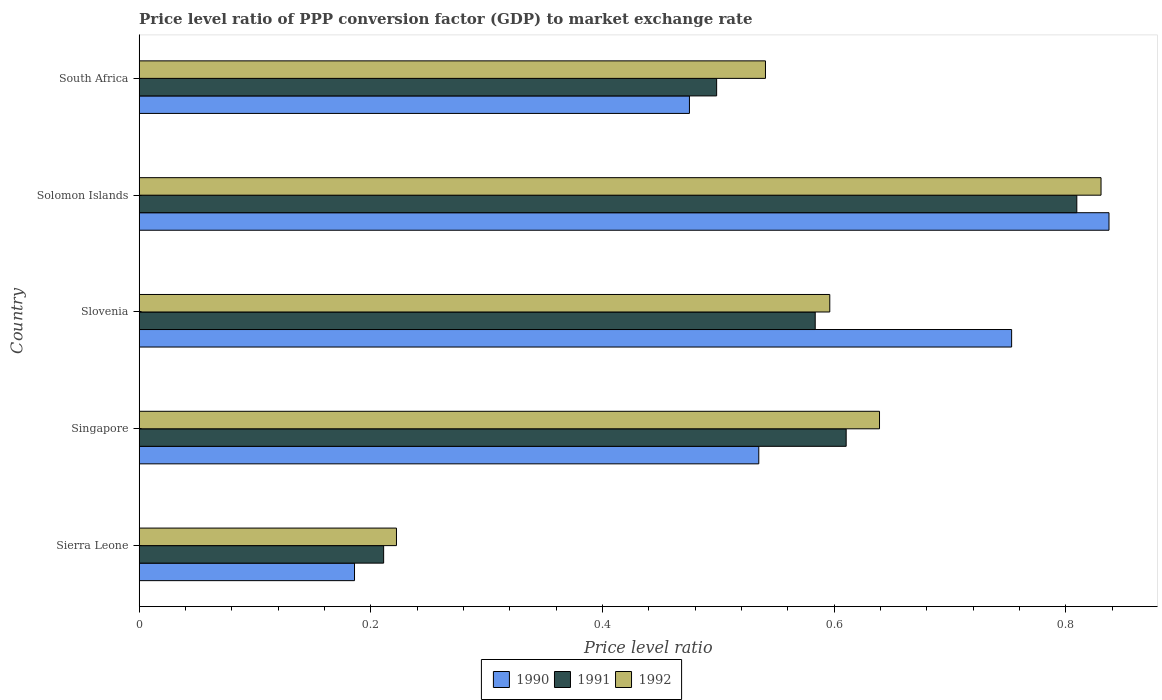How many groups of bars are there?
Your answer should be compact. 5. What is the label of the 5th group of bars from the top?
Your response must be concise. Sierra Leone. What is the price level ratio in 1991 in South Africa?
Make the answer very short. 0.5. Across all countries, what is the maximum price level ratio in 1991?
Your answer should be very brief. 0.81. Across all countries, what is the minimum price level ratio in 1990?
Provide a succinct answer. 0.19. In which country was the price level ratio in 1992 maximum?
Your answer should be compact. Solomon Islands. In which country was the price level ratio in 1991 minimum?
Your response must be concise. Sierra Leone. What is the total price level ratio in 1992 in the graph?
Ensure brevity in your answer.  2.83. What is the difference between the price level ratio in 1992 in Sierra Leone and that in Solomon Islands?
Provide a short and direct response. -0.61. What is the difference between the price level ratio in 1990 in Sierra Leone and the price level ratio in 1992 in Singapore?
Offer a very short reply. -0.45. What is the average price level ratio in 1990 per country?
Make the answer very short. 0.56. What is the difference between the price level ratio in 1992 and price level ratio in 1991 in Slovenia?
Give a very brief answer. 0.01. What is the ratio of the price level ratio in 1991 in Singapore to that in Solomon Islands?
Offer a very short reply. 0.75. Is the difference between the price level ratio in 1992 in Slovenia and Solomon Islands greater than the difference between the price level ratio in 1991 in Slovenia and Solomon Islands?
Give a very brief answer. No. What is the difference between the highest and the second highest price level ratio in 1992?
Give a very brief answer. 0.19. What is the difference between the highest and the lowest price level ratio in 1992?
Make the answer very short. 0.61. In how many countries, is the price level ratio in 1992 greater than the average price level ratio in 1992 taken over all countries?
Provide a succinct answer. 3. Is the sum of the price level ratio in 1991 in Sierra Leone and Solomon Islands greater than the maximum price level ratio in 1992 across all countries?
Make the answer very short. Yes. What does the 3rd bar from the top in South Africa represents?
Offer a terse response. 1990. What does the 2nd bar from the bottom in Solomon Islands represents?
Give a very brief answer. 1991. Is it the case that in every country, the sum of the price level ratio in 1991 and price level ratio in 1990 is greater than the price level ratio in 1992?
Your response must be concise. Yes. How many bars are there?
Your response must be concise. 15. What is the difference between two consecutive major ticks on the X-axis?
Provide a succinct answer. 0.2. Where does the legend appear in the graph?
Give a very brief answer. Bottom center. What is the title of the graph?
Ensure brevity in your answer.  Price level ratio of PPP conversion factor (GDP) to market exchange rate. What is the label or title of the X-axis?
Provide a short and direct response. Price level ratio. What is the Price level ratio of 1990 in Sierra Leone?
Give a very brief answer. 0.19. What is the Price level ratio of 1991 in Sierra Leone?
Your answer should be very brief. 0.21. What is the Price level ratio in 1992 in Sierra Leone?
Offer a very short reply. 0.22. What is the Price level ratio of 1990 in Singapore?
Your answer should be compact. 0.53. What is the Price level ratio in 1991 in Singapore?
Offer a terse response. 0.61. What is the Price level ratio in 1992 in Singapore?
Your response must be concise. 0.64. What is the Price level ratio of 1990 in Slovenia?
Give a very brief answer. 0.75. What is the Price level ratio of 1991 in Slovenia?
Your response must be concise. 0.58. What is the Price level ratio of 1992 in Slovenia?
Give a very brief answer. 0.6. What is the Price level ratio in 1990 in Solomon Islands?
Provide a succinct answer. 0.84. What is the Price level ratio in 1991 in Solomon Islands?
Make the answer very short. 0.81. What is the Price level ratio of 1992 in Solomon Islands?
Your answer should be compact. 0.83. What is the Price level ratio of 1990 in South Africa?
Your answer should be compact. 0.48. What is the Price level ratio in 1991 in South Africa?
Give a very brief answer. 0.5. What is the Price level ratio in 1992 in South Africa?
Offer a terse response. 0.54. Across all countries, what is the maximum Price level ratio of 1990?
Keep it short and to the point. 0.84. Across all countries, what is the maximum Price level ratio of 1991?
Your response must be concise. 0.81. Across all countries, what is the maximum Price level ratio of 1992?
Provide a short and direct response. 0.83. Across all countries, what is the minimum Price level ratio of 1990?
Provide a short and direct response. 0.19. Across all countries, what is the minimum Price level ratio in 1991?
Your response must be concise. 0.21. Across all countries, what is the minimum Price level ratio in 1992?
Provide a succinct answer. 0.22. What is the total Price level ratio in 1990 in the graph?
Provide a short and direct response. 2.79. What is the total Price level ratio in 1991 in the graph?
Your answer should be very brief. 2.71. What is the total Price level ratio of 1992 in the graph?
Give a very brief answer. 2.83. What is the difference between the Price level ratio of 1990 in Sierra Leone and that in Singapore?
Provide a succinct answer. -0.35. What is the difference between the Price level ratio of 1991 in Sierra Leone and that in Singapore?
Provide a short and direct response. -0.4. What is the difference between the Price level ratio of 1992 in Sierra Leone and that in Singapore?
Offer a very short reply. -0.42. What is the difference between the Price level ratio in 1990 in Sierra Leone and that in Slovenia?
Give a very brief answer. -0.57. What is the difference between the Price level ratio in 1991 in Sierra Leone and that in Slovenia?
Provide a succinct answer. -0.37. What is the difference between the Price level ratio of 1992 in Sierra Leone and that in Slovenia?
Your answer should be very brief. -0.37. What is the difference between the Price level ratio in 1990 in Sierra Leone and that in Solomon Islands?
Offer a very short reply. -0.65. What is the difference between the Price level ratio in 1991 in Sierra Leone and that in Solomon Islands?
Provide a short and direct response. -0.6. What is the difference between the Price level ratio in 1992 in Sierra Leone and that in Solomon Islands?
Keep it short and to the point. -0.61. What is the difference between the Price level ratio of 1990 in Sierra Leone and that in South Africa?
Your response must be concise. -0.29. What is the difference between the Price level ratio of 1991 in Sierra Leone and that in South Africa?
Offer a very short reply. -0.29. What is the difference between the Price level ratio in 1992 in Sierra Leone and that in South Africa?
Give a very brief answer. -0.32. What is the difference between the Price level ratio in 1990 in Singapore and that in Slovenia?
Your response must be concise. -0.22. What is the difference between the Price level ratio in 1991 in Singapore and that in Slovenia?
Your answer should be very brief. 0.03. What is the difference between the Price level ratio in 1992 in Singapore and that in Slovenia?
Your answer should be very brief. 0.04. What is the difference between the Price level ratio in 1990 in Singapore and that in Solomon Islands?
Keep it short and to the point. -0.3. What is the difference between the Price level ratio in 1991 in Singapore and that in Solomon Islands?
Make the answer very short. -0.2. What is the difference between the Price level ratio in 1992 in Singapore and that in Solomon Islands?
Your answer should be compact. -0.19. What is the difference between the Price level ratio in 1990 in Singapore and that in South Africa?
Give a very brief answer. 0.06. What is the difference between the Price level ratio in 1991 in Singapore and that in South Africa?
Make the answer very short. 0.11. What is the difference between the Price level ratio in 1992 in Singapore and that in South Africa?
Offer a terse response. 0.1. What is the difference between the Price level ratio of 1990 in Slovenia and that in Solomon Islands?
Your response must be concise. -0.08. What is the difference between the Price level ratio of 1991 in Slovenia and that in Solomon Islands?
Offer a terse response. -0.23. What is the difference between the Price level ratio in 1992 in Slovenia and that in Solomon Islands?
Offer a terse response. -0.23. What is the difference between the Price level ratio in 1990 in Slovenia and that in South Africa?
Provide a short and direct response. 0.28. What is the difference between the Price level ratio of 1991 in Slovenia and that in South Africa?
Keep it short and to the point. 0.09. What is the difference between the Price level ratio in 1992 in Slovenia and that in South Africa?
Give a very brief answer. 0.06. What is the difference between the Price level ratio of 1990 in Solomon Islands and that in South Africa?
Your answer should be compact. 0.36. What is the difference between the Price level ratio in 1991 in Solomon Islands and that in South Africa?
Offer a very short reply. 0.31. What is the difference between the Price level ratio of 1992 in Solomon Islands and that in South Africa?
Provide a succinct answer. 0.29. What is the difference between the Price level ratio of 1990 in Sierra Leone and the Price level ratio of 1991 in Singapore?
Give a very brief answer. -0.42. What is the difference between the Price level ratio of 1990 in Sierra Leone and the Price level ratio of 1992 in Singapore?
Your response must be concise. -0.45. What is the difference between the Price level ratio of 1991 in Sierra Leone and the Price level ratio of 1992 in Singapore?
Provide a succinct answer. -0.43. What is the difference between the Price level ratio of 1990 in Sierra Leone and the Price level ratio of 1991 in Slovenia?
Ensure brevity in your answer.  -0.4. What is the difference between the Price level ratio of 1990 in Sierra Leone and the Price level ratio of 1992 in Slovenia?
Ensure brevity in your answer.  -0.41. What is the difference between the Price level ratio in 1991 in Sierra Leone and the Price level ratio in 1992 in Slovenia?
Your response must be concise. -0.39. What is the difference between the Price level ratio in 1990 in Sierra Leone and the Price level ratio in 1991 in Solomon Islands?
Make the answer very short. -0.62. What is the difference between the Price level ratio in 1990 in Sierra Leone and the Price level ratio in 1992 in Solomon Islands?
Provide a short and direct response. -0.64. What is the difference between the Price level ratio in 1991 in Sierra Leone and the Price level ratio in 1992 in Solomon Islands?
Your answer should be very brief. -0.62. What is the difference between the Price level ratio of 1990 in Sierra Leone and the Price level ratio of 1991 in South Africa?
Provide a succinct answer. -0.31. What is the difference between the Price level ratio in 1990 in Sierra Leone and the Price level ratio in 1992 in South Africa?
Ensure brevity in your answer.  -0.35. What is the difference between the Price level ratio of 1991 in Sierra Leone and the Price level ratio of 1992 in South Africa?
Your answer should be very brief. -0.33. What is the difference between the Price level ratio in 1990 in Singapore and the Price level ratio in 1991 in Slovenia?
Offer a terse response. -0.05. What is the difference between the Price level ratio in 1990 in Singapore and the Price level ratio in 1992 in Slovenia?
Provide a succinct answer. -0.06. What is the difference between the Price level ratio of 1991 in Singapore and the Price level ratio of 1992 in Slovenia?
Offer a terse response. 0.01. What is the difference between the Price level ratio of 1990 in Singapore and the Price level ratio of 1991 in Solomon Islands?
Make the answer very short. -0.27. What is the difference between the Price level ratio of 1990 in Singapore and the Price level ratio of 1992 in Solomon Islands?
Offer a terse response. -0.3. What is the difference between the Price level ratio in 1991 in Singapore and the Price level ratio in 1992 in Solomon Islands?
Ensure brevity in your answer.  -0.22. What is the difference between the Price level ratio of 1990 in Singapore and the Price level ratio of 1991 in South Africa?
Your answer should be compact. 0.04. What is the difference between the Price level ratio in 1990 in Singapore and the Price level ratio in 1992 in South Africa?
Give a very brief answer. -0.01. What is the difference between the Price level ratio in 1991 in Singapore and the Price level ratio in 1992 in South Africa?
Your answer should be compact. 0.07. What is the difference between the Price level ratio in 1990 in Slovenia and the Price level ratio in 1991 in Solomon Islands?
Ensure brevity in your answer.  -0.06. What is the difference between the Price level ratio in 1990 in Slovenia and the Price level ratio in 1992 in Solomon Islands?
Your response must be concise. -0.08. What is the difference between the Price level ratio in 1991 in Slovenia and the Price level ratio in 1992 in Solomon Islands?
Your response must be concise. -0.25. What is the difference between the Price level ratio of 1990 in Slovenia and the Price level ratio of 1991 in South Africa?
Provide a short and direct response. 0.25. What is the difference between the Price level ratio in 1990 in Slovenia and the Price level ratio in 1992 in South Africa?
Your answer should be very brief. 0.21. What is the difference between the Price level ratio in 1991 in Slovenia and the Price level ratio in 1992 in South Africa?
Keep it short and to the point. 0.04. What is the difference between the Price level ratio in 1990 in Solomon Islands and the Price level ratio in 1991 in South Africa?
Offer a terse response. 0.34. What is the difference between the Price level ratio of 1990 in Solomon Islands and the Price level ratio of 1992 in South Africa?
Provide a succinct answer. 0.3. What is the difference between the Price level ratio of 1991 in Solomon Islands and the Price level ratio of 1992 in South Africa?
Provide a short and direct response. 0.27. What is the average Price level ratio in 1990 per country?
Offer a terse response. 0.56. What is the average Price level ratio in 1991 per country?
Offer a terse response. 0.54. What is the average Price level ratio of 1992 per country?
Your response must be concise. 0.57. What is the difference between the Price level ratio in 1990 and Price level ratio in 1991 in Sierra Leone?
Offer a very short reply. -0.03. What is the difference between the Price level ratio of 1990 and Price level ratio of 1992 in Sierra Leone?
Provide a short and direct response. -0.04. What is the difference between the Price level ratio in 1991 and Price level ratio in 1992 in Sierra Leone?
Offer a very short reply. -0.01. What is the difference between the Price level ratio in 1990 and Price level ratio in 1991 in Singapore?
Make the answer very short. -0.08. What is the difference between the Price level ratio of 1990 and Price level ratio of 1992 in Singapore?
Your answer should be compact. -0.1. What is the difference between the Price level ratio in 1991 and Price level ratio in 1992 in Singapore?
Offer a terse response. -0.03. What is the difference between the Price level ratio in 1990 and Price level ratio in 1991 in Slovenia?
Your response must be concise. 0.17. What is the difference between the Price level ratio in 1990 and Price level ratio in 1992 in Slovenia?
Offer a terse response. 0.16. What is the difference between the Price level ratio of 1991 and Price level ratio of 1992 in Slovenia?
Make the answer very short. -0.01. What is the difference between the Price level ratio of 1990 and Price level ratio of 1991 in Solomon Islands?
Your answer should be very brief. 0.03. What is the difference between the Price level ratio in 1990 and Price level ratio in 1992 in Solomon Islands?
Your answer should be compact. 0.01. What is the difference between the Price level ratio of 1991 and Price level ratio of 1992 in Solomon Islands?
Your answer should be compact. -0.02. What is the difference between the Price level ratio in 1990 and Price level ratio in 1991 in South Africa?
Provide a succinct answer. -0.02. What is the difference between the Price level ratio in 1990 and Price level ratio in 1992 in South Africa?
Your answer should be compact. -0.07. What is the difference between the Price level ratio in 1991 and Price level ratio in 1992 in South Africa?
Your answer should be very brief. -0.04. What is the ratio of the Price level ratio in 1990 in Sierra Leone to that in Singapore?
Your response must be concise. 0.35. What is the ratio of the Price level ratio of 1991 in Sierra Leone to that in Singapore?
Your answer should be very brief. 0.35. What is the ratio of the Price level ratio in 1992 in Sierra Leone to that in Singapore?
Ensure brevity in your answer.  0.35. What is the ratio of the Price level ratio in 1990 in Sierra Leone to that in Slovenia?
Your answer should be very brief. 0.25. What is the ratio of the Price level ratio of 1991 in Sierra Leone to that in Slovenia?
Ensure brevity in your answer.  0.36. What is the ratio of the Price level ratio of 1992 in Sierra Leone to that in Slovenia?
Provide a succinct answer. 0.37. What is the ratio of the Price level ratio of 1990 in Sierra Leone to that in Solomon Islands?
Your answer should be compact. 0.22. What is the ratio of the Price level ratio of 1991 in Sierra Leone to that in Solomon Islands?
Make the answer very short. 0.26. What is the ratio of the Price level ratio of 1992 in Sierra Leone to that in Solomon Islands?
Ensure brevity in your answer.  0.27. What is the ratio of the Price level ratio of 1990 in Sierra Leone to that in South Africa?
Your answer should be compact. 0.39. What is the ratio of the Price level ratio of 1991 in Sierra Leone to that in South Africa?
Provide a short and direct response. 0.42. What is the ratio of the Price level ratio in 1992 in Sierra Leone to that in South Africa?
Offer a terse response. 0.41. What is the ratio of the Price level ratio of 1990 in Singapore to that in Slovenia?
Offer a very short reply. 0.71. What is the ratio of the Price level ratio in 1991 in Singapore to that in Slovenia?
Give a very brief answer. 1.05. What is the ratio of the Price level ratio in 1992 in Singapore to that in Slovenia?
Your answer should be very brief. 1.07. What is the ratio of the Price level ratio in 1990 in Singapore to that in Solomon Islands?
Your response must be concise. 0.64. What is the ratio of the Price level ratio in 1991 in Singapore to that in Solomon Islands?
Keep it short and to the point. 0.75. What is the ratio of the Price level ratio in 1992 in Singapore to that in Solomon Islands?
Provide a short and direct response. 0.77. What is the ratio of the Price level ratio of 1990 in Singapore to that in South Africa?
Offer a very short reply. 1.13. What is the ratio of the Price level ratio in 1991 in Singapore to that in South Africa?
Your response must be concise. 1.22. What is the ratio of the Price level ratio of 1992 in Singapore to that in South Africa?
Give a very brief answer. 1.18. What is the ratio of the Price level ratio in 1990 in Slovenia to that in Solomon Islands?
Your answer should be compact. 0.9. What is the ratio of the Price level ratio of 1991 in Slovenia to that in Solomon Islands?
Offer a terse response. 0.72. What is the ratio of the Price level ratio of 1992 in Slovenia to that in Solomon Islands?
Make the answer very short. 0.72. What is the ratio of the Price level ratio of 1990 in Slovenia to that in South Africa?
Give a very brief answer. 1.59. What is the ratio of the Price level ratio of 1991 in Slovenia to that in South Africa?
Keep it short and to the point. 1.17. What is the ratio of the Price level ratio of 1992 in Slovenia to that in South Africa?
Provide a succinct answer. 1.1. What is the ratio of the Price level ratio in 1990 in Solomon Islands to that in South Africa?
Provide a succinct answer. 1.76. What is the ratio of the Price level ratio in 1991 in Solomon Islands to that in South Africa?
Provide a succinct answer. 1.62. What is the ratio of the Price level ratio in 1992 in Solomon Islands to that in South Africa?
Your answer should be very brief. 1.54. What is the difference between the highest and the second highest Price level ratio in 1990?
Your answer should be very brief. 0.08. What is the difference between the highest and the second highest Price level ratio of 1991?
Your answer should be compact. 0.2. What is the difference between the highest and the second highest Price level ratio of 1992?
Provide a short and direct response. 0.19. What is the difference between the highest and the lowest Price level ratio of 1990?
Provide a succinct answer. 0.65. What is the difference between the highest and the lowest Price level ratio in 1991?
Ensure brevity in your answer.  0.6. What is the difference between the highest and the lowest Price level ratio in 1992?
Your response must be concise. 0.61. 